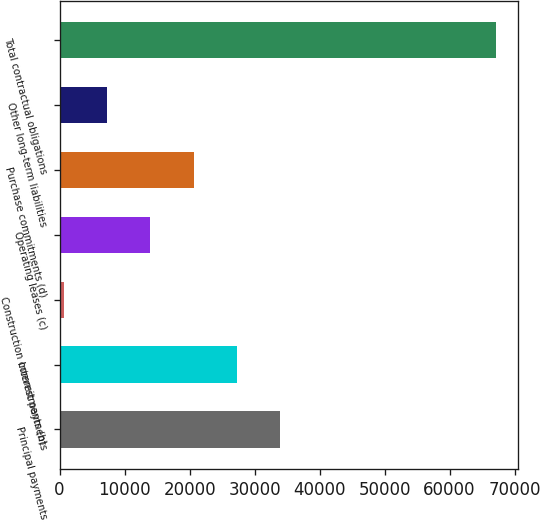Convert chart to OTSL. <chart><loc_0><loc_0><loc_500><loc_500><bar_chart><fcel>Principal payments<fcel>Interest payments<fcel>Construction commitments (b)<fcel>Operating leases (c)<fcel>Purchase commitments (d)<fcel>Other long-term liabilities<fcel>Total contractual obligations<nl><fcel>33910.5<fcel>27264.6<fcel>681<fcel>13972.8<fcel>20618.7<fcel>7326.9<fcel>67140<nl></chart> 